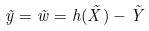Convert formula to latex. <formula><loc_0><loc_0><loc_500><loc_500>\tilde { y } = \tilde { w } = h ( \tilde { X } ) - \tilde { Y }</formula> 